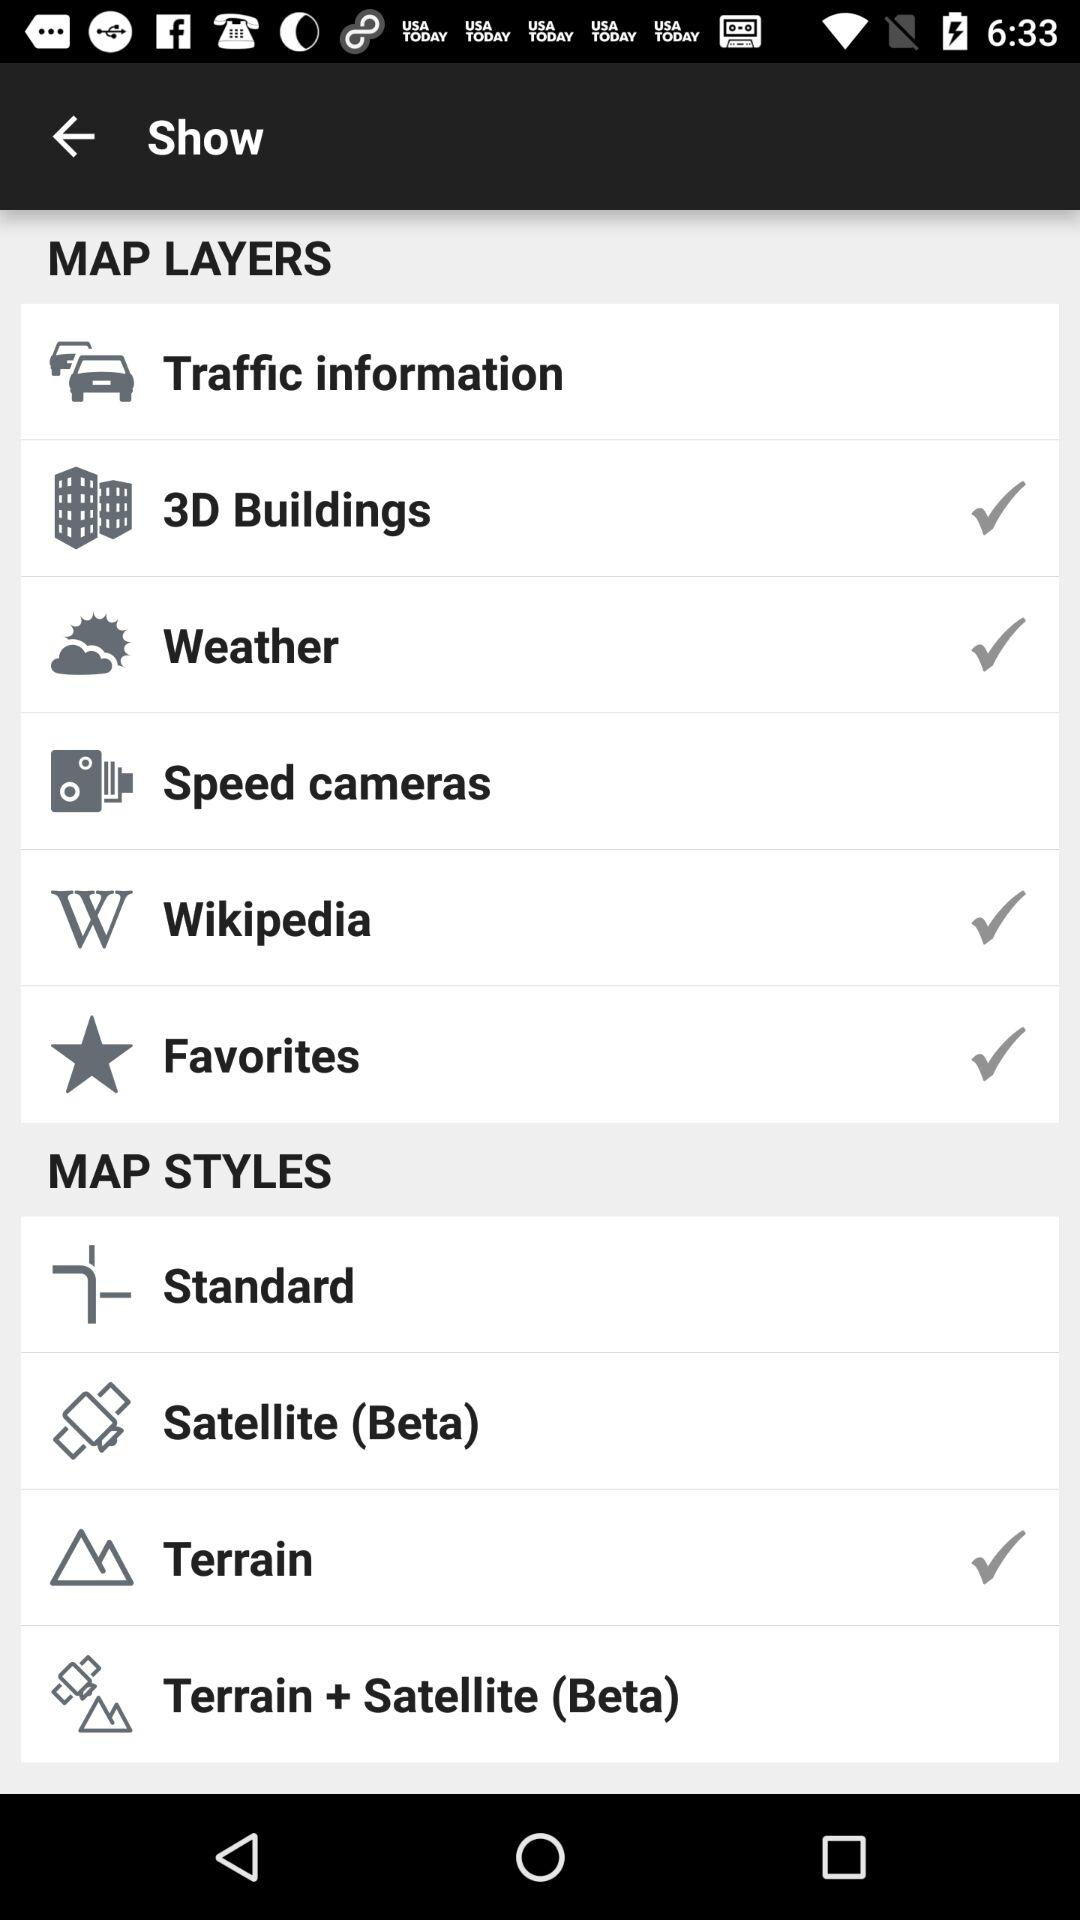What are the options in "MAP LAYERS"? The options are "Traffic information", "3D Buildings", "Weather", "Speed cameras", "Wikipedia" and "Favorites". 